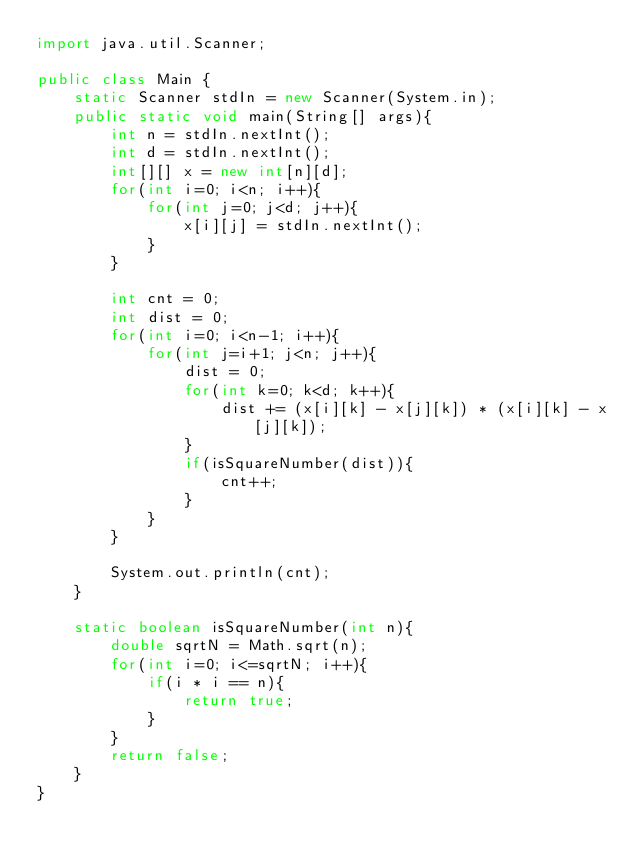Convert code to text. <code><loc_0><loc_0><loc_500><loc_500><_Java_>import java.util.Scanner;

public class Main {
    static Scanner stdIn = new Scanner(System.in);
    public static void main(String[] args){
        int n = stdIn.nextInt();
        int d = stdIn.nextInt();
        int[][] x = new int[n][d];
        for(int i=0; i<n; i++){
            for(int j=0; j<d; j++){
                x[i][j] = stdIn.nextInt();
            }
        }

        int cnt = 0;
        int dist = 0;
        for(int i=0; i<n-1; i++){
            for(int j=i+1; j<n; j++){
                dist = 0;
                for(int k=0; k<d; k++){
                    dist += (x[i][k] - x[j][k]) * (x[i][k] - x[j][k]);
                }
                if(isSquareNumber(dist)){
                    cnt++;
                }
            }
        }

        System.out.println(cnt);
    }
    
    static boolean isSquareNumber(int n){
        double sqrtN = Math.sqrt(n);
        for(int i=0; i<=sqrtN; i++){
            if(i * i == n){
                return true;
            }
        }
        return false;
    }
}
</code> 